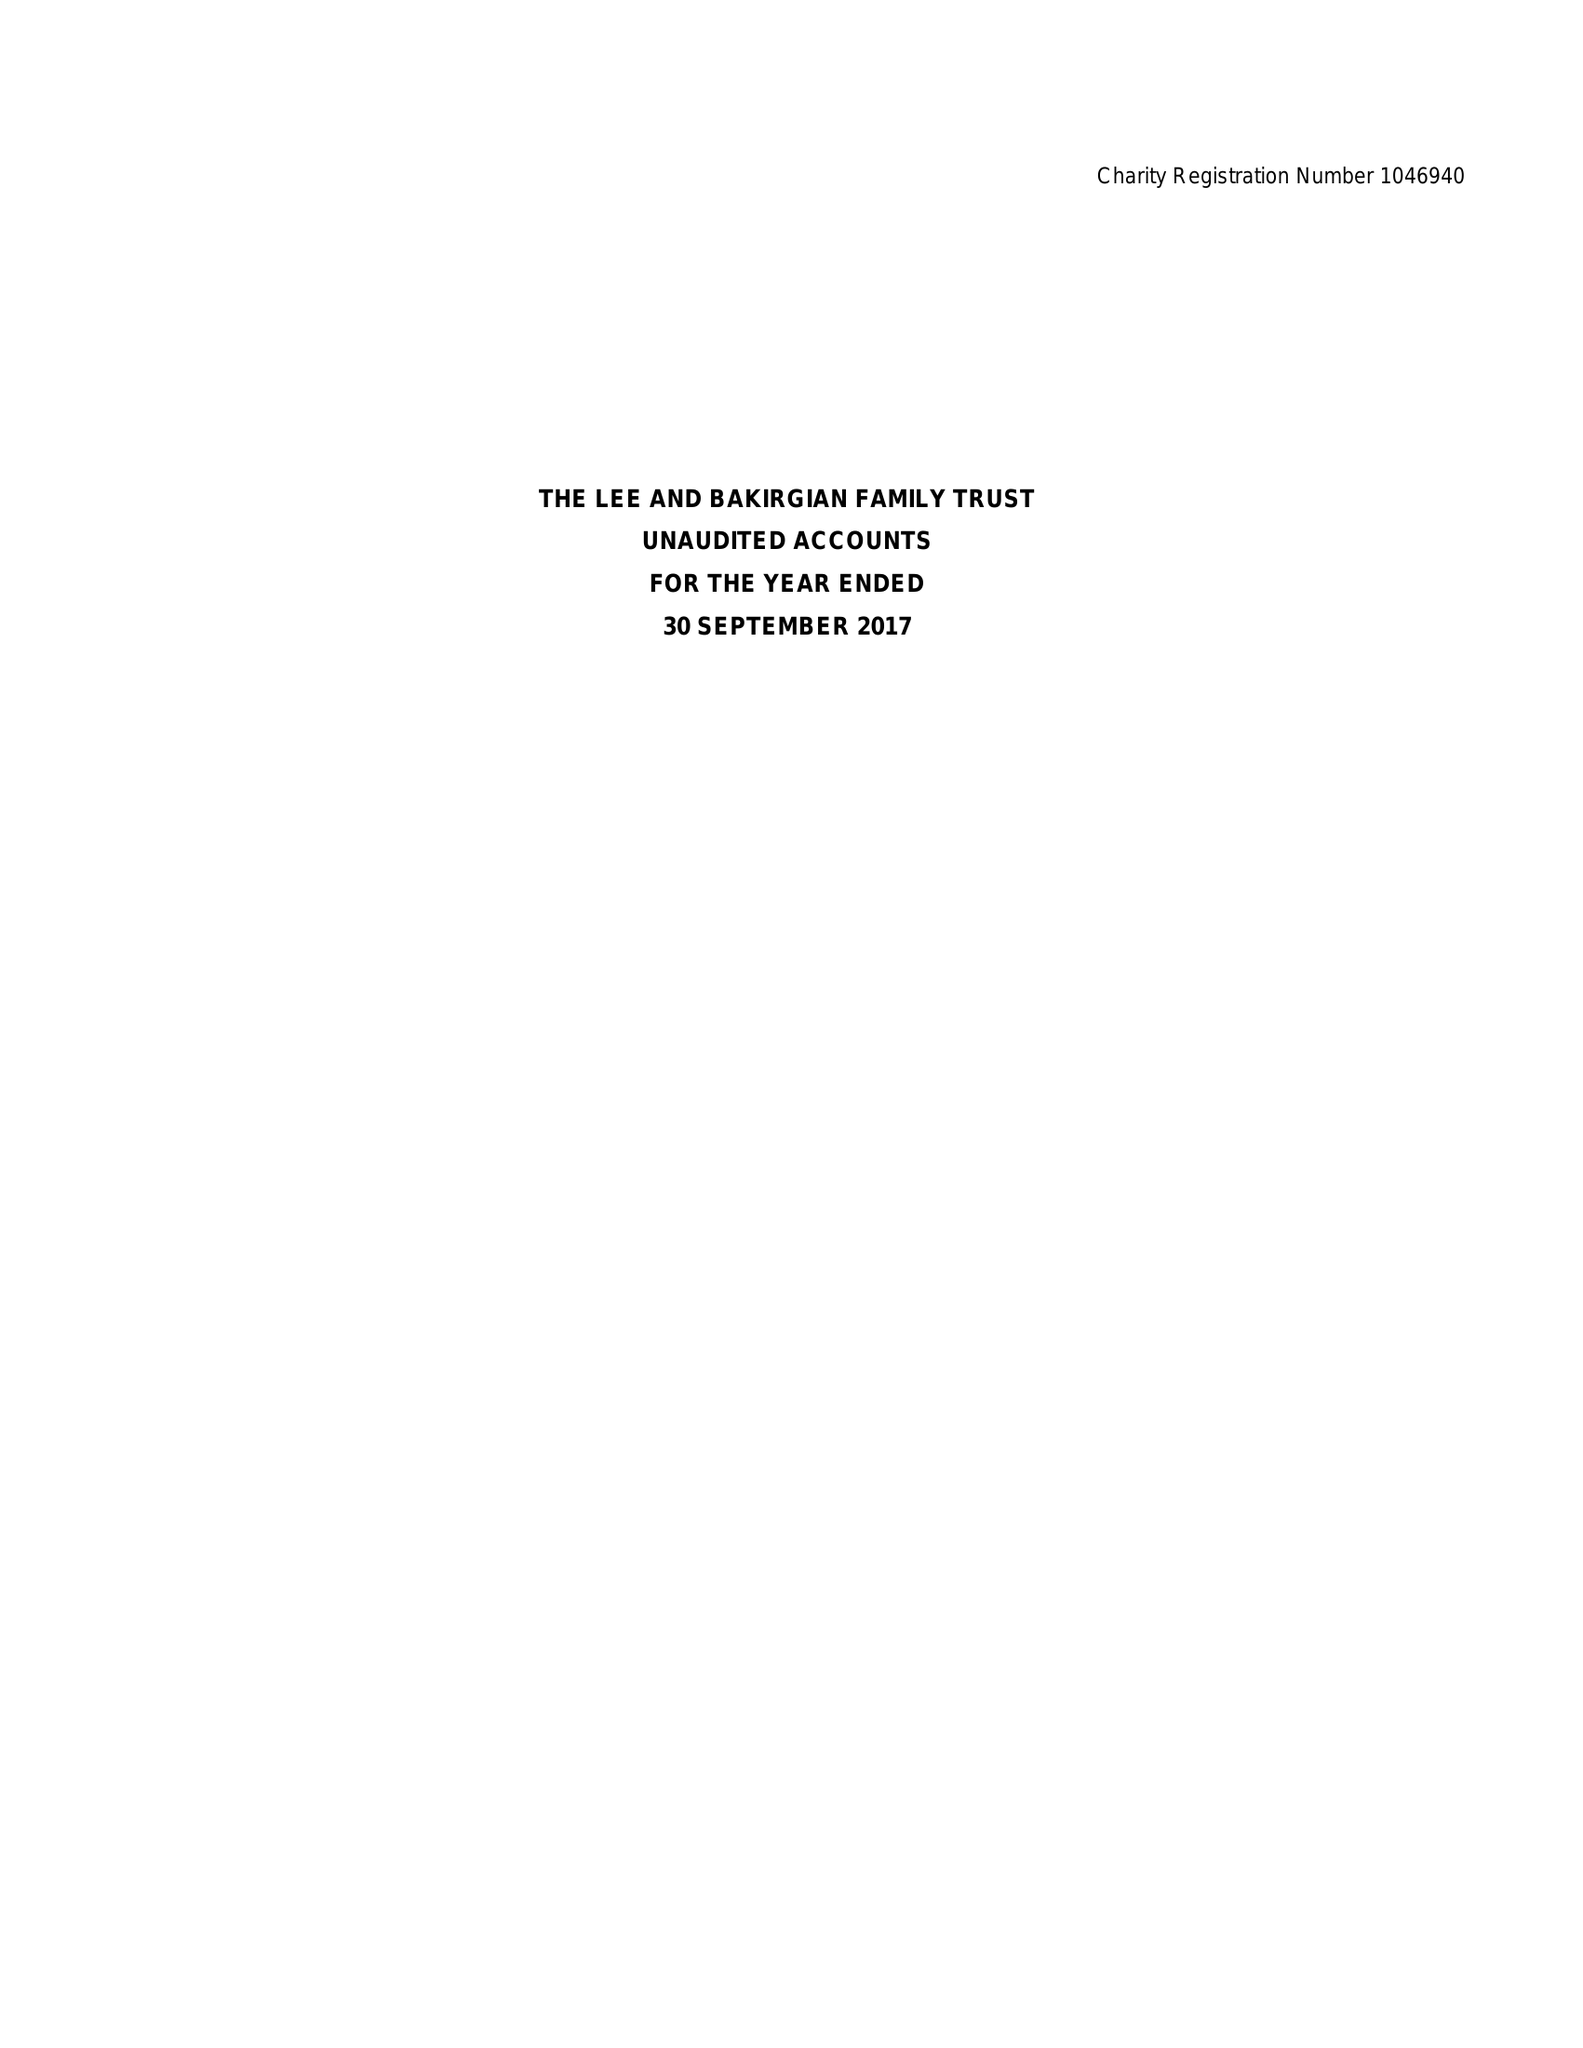What is the value for the spending_annually_in_british_pounds?
Answer the question using a single word or phrase. 24628.00 